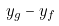<formula> <loc_0><loc_0><loc_500><loc_500>y _ { g } - y _ { f }</formula> 